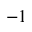<formula> <loc_0><loc_0><loc_500><loc_500>- 1</formula> 